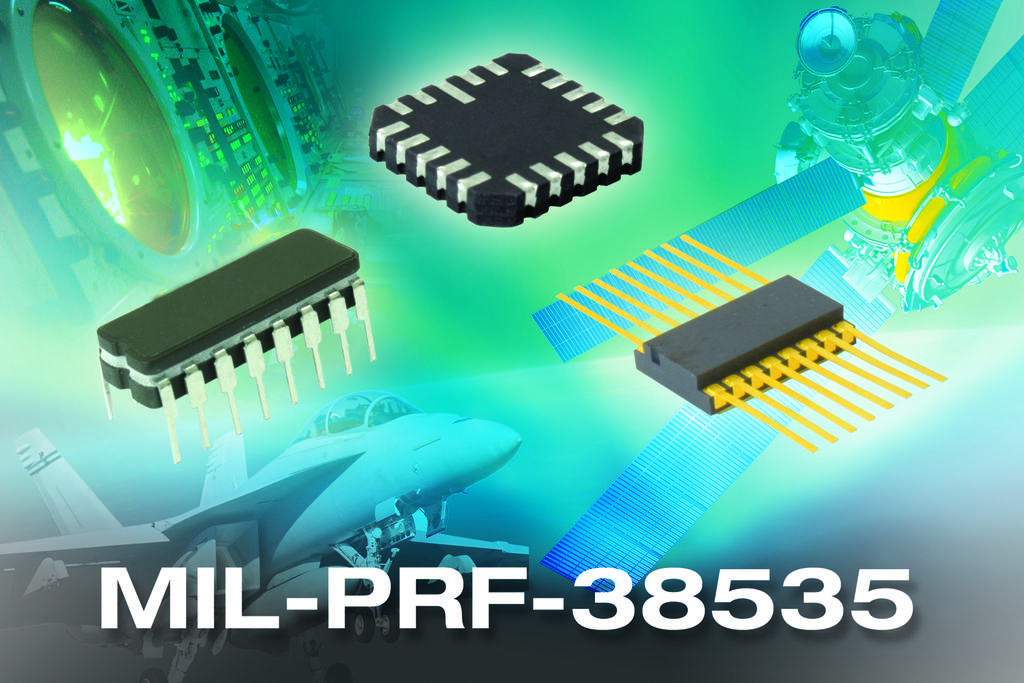What is the model number?
Ensure brevity in your answer.  Mil-prf-38535. What are the first three letters?
Give a very brief answer. Mil. 